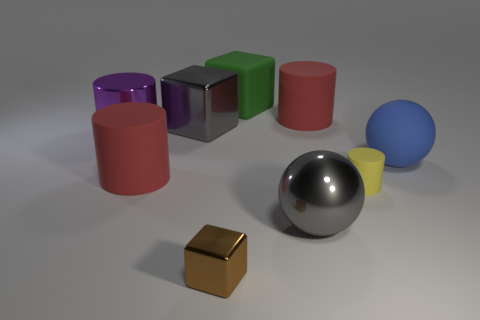There is a object that is both in front of the big blue rubber object and to the left of the large gray cube; what is its color?
Keep it short and to the point. Red. Are there any other things that are the same color as the rubber cube?
Ensure brevity in your answer.  No. What color is the cylinder on the right side of the large red object that is to the right of the big matte block?
Ensure brevity in your answer.  Yellow. Do the yellow cylinder and the green thing have the same size?
Provide a succinct answer. No. Are the big red cylinder that is right of the gray metal sphere and the big gray cube that is behind the large purple thing made of the same material?
Your response must be concise. No. The red matte object that is on the right side of the ball that is in front of the matte object on the left side of the small metallic block is what shape?
Give a very brief answer. Cylinder. Is the number of large red things greater than the number of tiny cyan metal cylinders?
Your response must be concise. Yes. Is there a ball?
Offer a very short reply. Yes. How many objects are big shiny things that are in front of the blue matte thing or large gray things in front of the big metal cube?
Your response must be concise. 1. Is the small rubber cylinder the same color as the big matte ball?
Give a very brief answer. No. 